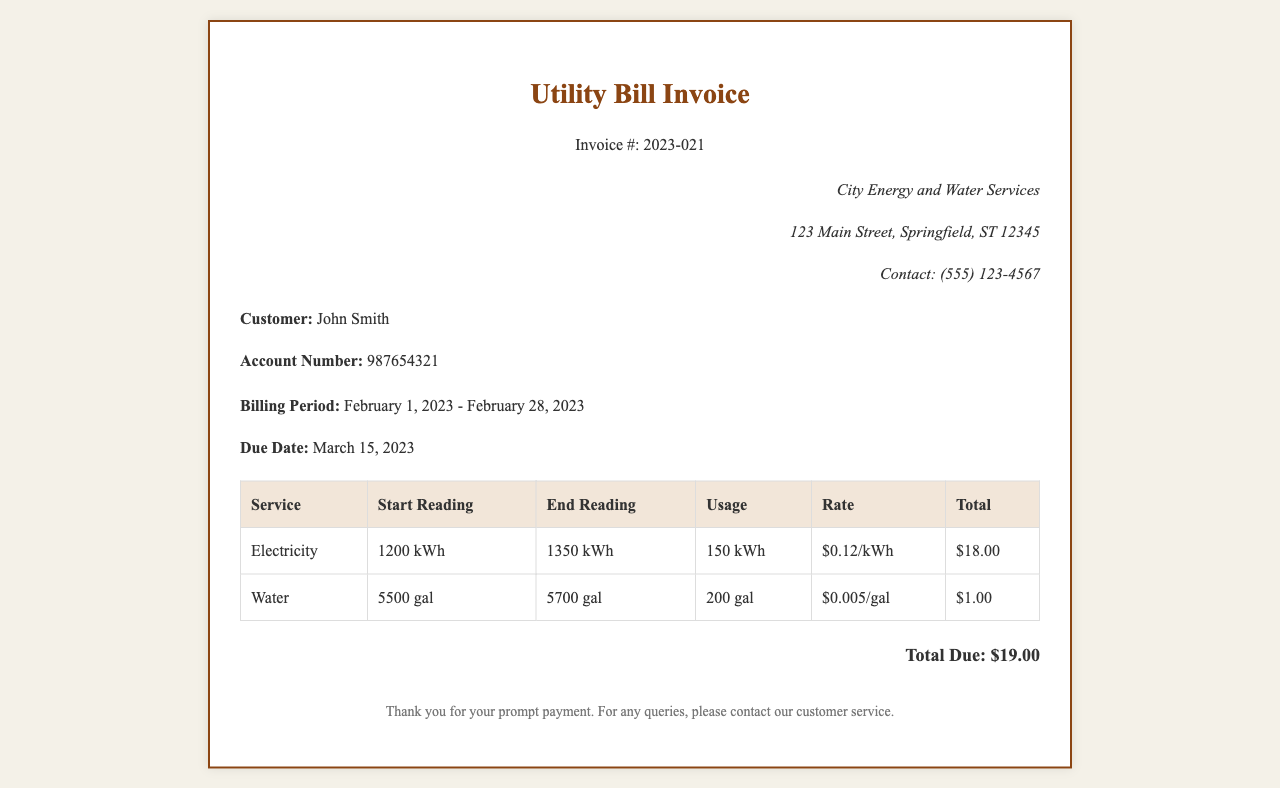What is the invoice number? The invoice number is listed in the header of the document as a unique identifier for the bill.
Answer: 2023-021 Who is the customer? The customer's name is presented in the customer info section of the document.
Answer: John Smith What is the billing period? The billing period is specified in the invoice details, indicating the duration of the services billed.
Answer: February 1, 2023 - February 28, 2023 What is the total due amount? The total due amount is calculated based on the itemized breakdown of services provided in the invoice.
Answer: $19.00 How much was charged for electricity usage? The total charge for electricity is listed in the itemized table as the sum of usage multiplied by the rate.
Answer: $18.00 What is the water usage in gallons? The water usage is indicated in the table as the difference between the start and end readings.
Answer: 200 gal What is the rate for water charged per gallon? The rate for water can be found in the itemized breakdown in the table detailing the service.
Answer: $0.005/gal What is the end reading for electricity? The end reading for electricity can be found in the itemized table along with the start reading.
Answer: 1350 kWh What company provided the utility services? The provider of the services is mentioned in the provider info section of the document.
Answer: City Energy and Water Services When is the due date for the payment? The due date is clearly listed in the invoice details section, specifying when the payment is expected.
Answer: March 15, 2023 